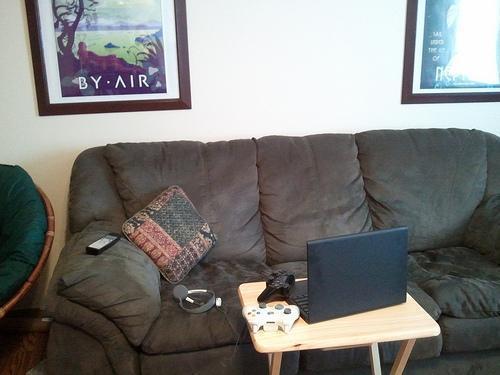How many remotes are on the table?
Give a very brief answer. 2. How many pillows on the sofa?
Give a very brief answer. 1. How many pictures on the wall?
Give a very brief answer. 2. How many pillows are there?
Give a very brief answer. 1. How many game consoles are there?
Give a very brief answer. 2. 